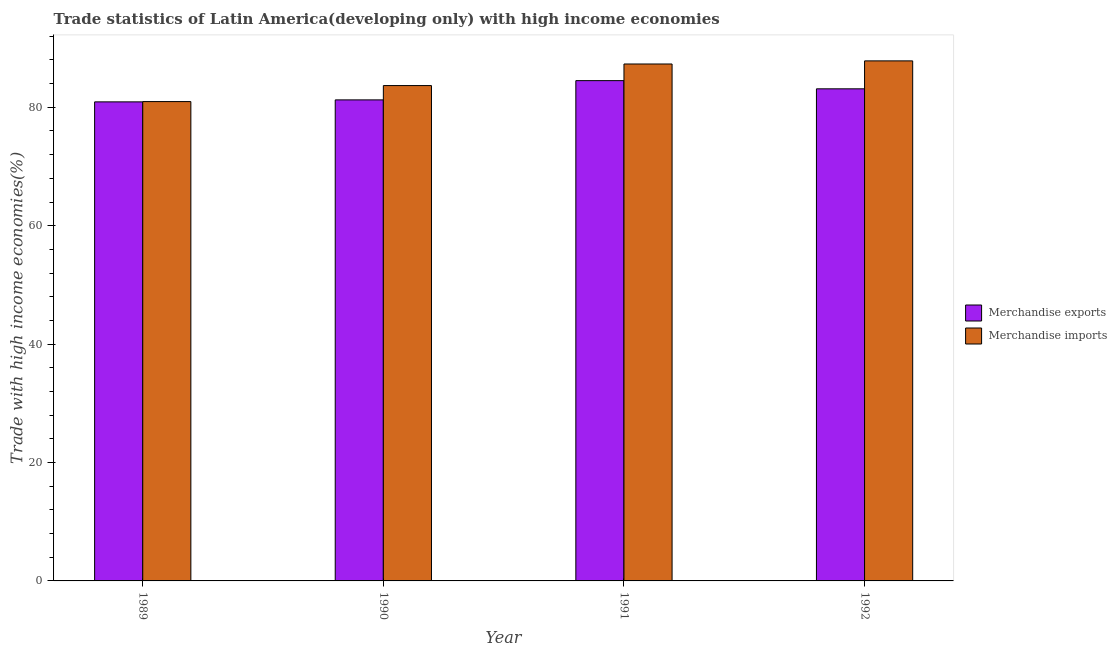How many groups of bars are there?
Your response must be concise. 4. Are the number of bars per tick equal to the number of legend labels?
Your answer should be compact. Yes. Are the number of bars on each tick of the X-axis equal?
Provide a short and direct response. Yes. How many bars are there on the 3rd tick from the left?
Give a very brief answer. 2. What is the label of the 1st group of bars from the left?
Keep it short and to the point. 1989. In how many cases, is the number of bars for a given year not equal to the number of legend labels?
Keep it short and to the point. 0. What is the merchandise imports in 1992?
Keep it short and to the point. 87.84. Across all years, what is the maximum merchandise imports?
Provide a succinct answer. 87.84. Across all years, what is the minimum merchandise exports?
Give a very brief answer. 80.92. What is the total merchandise exports in the graph?
Give a very brief answer. 329.81. What is the difference between the merchandise exports in 1990 and that in 1991?
Keep it short and to the point. -3.25. What is the difference between the merchandise imports in 1992 and the merchandise exports in 1991?
Your response must be concise. 0.53. What is the average merchandise imports per year?
Your response must be concise. 84.95. In how many years, is the merchandise exports greater than 56 %?
Make the answer very short. 4. What is the ratio of the merchandise exports in 1989 to that in 1992?
Offer a very short reply. 0.97. What is the difference between the highest and the second highest merchandise exports?
Provide a short and direct response. 1.38. What is the difference between the highest and the lowest merchandise imports?
Keep it short and to the point. 6.88. What does the 1st bar from the right in 1992 represents?
Offer a terse response. Merchandise imports. How many bars are there?
Ensure brevity in your answer.  8. How many years are there in the graph?
Give a very brief answer. 4. What is the difference between two consecutive major ticks on the Y-axis?
Give a very brief answer. 20. Are the values on the major ticks of Y-axis written in scientific E-notation?
Your answer should be very brief. No. Does the graph contain any zero values?
Provide a short and direct response. No. Does the graph contain grids?
Your answer should be compact. No. How many legend labels are there?
Your answer should be compact. 2. What is the title of the graph?
Your answer should be very brief. Trade statistics of Latin America(developing only) with high income economies. Does "All education staff compensation" appear as one of the legend labels in the graph?
Offer a terse response. No. What is the label or title of the Y-axis?
Give a very brief answer. Trade with high income economies(%). What is the Trade with high income economies(%) in Merchandise exports in 1989?
Offer a terse response. 80.92. What is the Trade with high income economies(%) of Merchandise imports in 1989?
Keep it short and to the point. 80.97. What is the Trade with high income economies(%) in Merchandise exports in 1990?
Keep it short and to the point. 81.26. What is the Trade with high income economies(%) in Merchandise imports in 1990?
Make the answer very short. 83.67. What is the Trade with high income economies(%) in Merchandise exports in 1991?
Provide a short and direct response. 84.51. What is the Trade with high income economies(%) of Merchandise imports in 1991?
Your answer should be very brief. 87.32. What is the Trade with high income economies(%) of Merchandise exports in 1992?
Provide a succinct answer. 83.12. What is the Trade with high income economies(%) of Merchandise imports in 1992?
Provide a succinct answer. 87.84. Across all years, what is the maximum Trade with high income economies(%) in Merchandise exports?
Keep it short and to the point. 84.51. Across all years, what is the maximum Trade with high income economies(%) of Merchandise imports?
Offer a terse response. 87.84. Across all years, what is the minimum Trade with high income economies(%) in Merchandise exports?
Offer a very short reply. 80.92. Across all years, what is the minimum Trade with high income economies(%) of Merchandise imports?
Offer a terse response. 80.97. What is the total Trade with high income economies(%) in Merchandise exports in the graph?
Ensure brevity in your answer.  329.81. What is the total Trade with high income economies(%) in Merchandise imports in the graph?
Your response must be concise. 339.8. What is the difference between the Trade with high income economies(%) of Merchandise exports in 1989 and that in 1990?
Provide a succinct answer. -0.33. What is the difference between the Trade with high income economies(%) in Merchandise imports in 1989 and that in 1990?
Provide a short and direct response. -2.71. What is the difference between the Trade with high income economies(%) in Merchandise exports in 1989 and that in 1991?
Ensure brevity in your answer.  -3.59. What is the difference between the Trade with high income economies(%) in Merchandise imports in 1989 and that in 1991?
Your answer should be very brief. -6.35. What is the difference between the Trade with high income economies(%) in Merchandise exports in 1989 and that in 1992?
Your answer should be very brief. -2.2. What is the difference between the Trade with high income economies(%) in Merchandise imports in 1989 and that in 1992?
Offer a very short reply. -6.88. What is the difference between the Trade with high income economies(%) in Merchandise exports in 1990 and that in 1991?
Make the answer very short. -3.25. What is the difference between the Trade with high income economies(%) of Merchandise imports in 1990 and that in 1991?
Offer a very short reply. -3.64. What is the difference between the Trade with high income economies(%) of Merchandise exports in 1990 and that in 1992?
Ensure brevity in your answer.  -1.87. What is the difference between the Trade with high income economies(%) of Merchandise imports in 1990 and that in 1992?
Offer a terse response. -4.17. What is the difference between the Trade with high income economies(%) in Merchandise exports in 1991 and that in 1992?
Provide a short and direct response. 1.38. What is the difference between the Trade with high income economies(%) in Merchandise imports in 1991 and that in 1992?
Offer a terse response. -0.53. What is the difference between the Trade with high income economies(%) in Merchandise exports in 1989 and the Trade with high income economies(%) in Merchandise imports in 1990?
Offer a very short reply. -2.75. What is the difference between the Trade with high income economies(%) in Merchandise exports in 1989 and the Trade with high income economies(%) in Merchandise imports in 1991?
Provide a short and direct response. -6.4. What is the difference between the Trade with high income economies(%) of Merchandise exports in 1989 and the Trade with high income economies(%) of Merchandise imports in 1992?
Your answer should be compact. -6.92. What is the difference between the Trade with high income economies(%) in Merchandise exports in 1990 and the Trade with high income economies(%) in Merchandise imports in 1991?
Your answer should be compact. -6.06. What is the difference between the Trade with high income economies(%) in Merchandise exports in 1990 and the Trade with high income economies(%) in Merchandise imports in 1992?
Offer a very short reply. -6.59. What is the difference between the Trade with high income economies(%) in Merchandise exports in 1991 and the Trade with high income economies(%) in Merchandise imports in 1992?
Ensure brevity in your answer.  -3.34. What is the average Trade with high income economies(%) of Merchandise exports per year?
Provide a short and direct response. 82.45. What is the average Trade with high income economies(%) in Merchandise imports per year?
Offer a very short reply. 84.95. In the year 1989, what is the difference between the Trade with high income economies(%) of Merchandise exports and Trade with high income economies(%) of Merchandise imports?
Ensure brevity in your answer.  -0.05. In the year 1990, what is the difference between the Trade with high income economies(%) of Merchandise exports and Trade with high income economies(%) of Merchandise imports?
Provide a short and direct response. -2.42. In the year 1991, what is the difference between the Trade with high income economies(%) in Merchandise exports and Trade with high income economies(%) in Merchandise imports?
Offer a very short reply. -2.81. In the year 1992, what is the difference between the Trade with high income economies(%) of Merchandise exports and Trade with high income economies(%) of Merchandise imports?
Keep it short and to the point. -4.72. What is the ratio of the Trade with high income economies(%) in Merchandise imports in 1989 to that in 1990?
Your answer should be very brief. 0.97. What is the ratio of the Trade with high income economies(%) in Merchandise exports in 1989 to that in 1991?
Make the answer very short. 0.96. What is the ratio of the Trade with high income economies(%) of Merchandise imports in 1989 to that in 1991?
Offer a terse response. 0.93. What is the ratio of the Trade with high income economies(%) in Merchandise exports in 1989 to that in 1992?
Give a very brief answer. 0.97. What is the ratio of the Trade with high income economies(%) of Merchandise imports in 1989 to that in 1992?
Ensure brevity in your answer.  0.92. What is the ratio of the Trade with high income economies(%) in Merchandise exports in 1990 to that in 1991?
Offer a very short reply. 0.96. What is the ratio of the Trade with high income economies(%) of Merchandise imports in 1990 to that in 1991?
Offer a terse response. 0.96. What is the ratio of the Trade with high income economies(%) of Merchandise exports in 1990 to that in 1992?
Provide a short and direct response. 0.98. What is the ratio of the Trade with high income economies(%) in Merchandise imports in 1990 to that in 1992?
Provide a succinct answer. 0.95. What is the ratio of the Trade with high income economies(%) in Merchandise exports in 1991 to that in 1992?
Your response must be concise. 1.02. What is the ratio of the Trade with high income economies(%) in Merchandise imports in 1991 to that in 1992?
Provide a succinct answer. 0.99. What is the difference between the highest and the second highest Trade with high income economies(%) of Merchandise exports?
Offer a terse response. 1.38. What is the difference between the highest and the second highest Trade with high income economies(%) in Merchandise imports?
Provide a short and direct response. 0.53. What is the difference between the highest and the lowest Trade with high income economies(%) in Merchandise exports?
Provide a short and direct response. 3.59. What is the difference between the highest and the lowest Trade with high income economies(%) in Merchandise imports?
Provide a short and direct response. 6.88. 